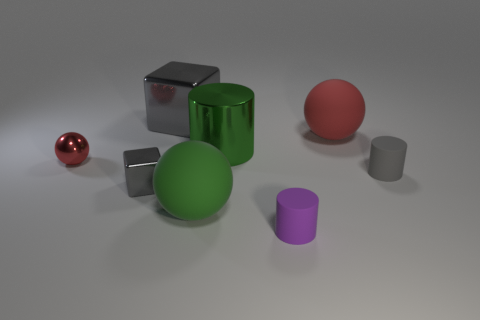Add 2 tiny purple rubber cylinders. How many objects exist? 10 Subtract all cylinders. How many objects are left? 5 Subtract all large blocks. Subtract all spheres. How many objects are left? 4 Add 6 red rubber objects. How many red rubber objects are left? 7 Add 1 green matte objects. How many green matte objects exist? 2 Subtract 1 red balls. How many objects are left? 7 